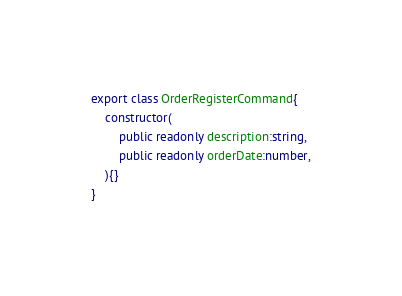<code> <loc_0><loc_0><loc_500><loc_500><_TypeScript_>export class OrderRegisterCommand{
    constructor(
        public readonly description:string,
        public readonly orderDate:number,
    ){}
}</code> 